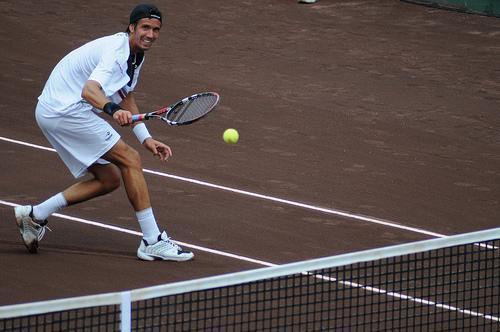How many people?
Give a very brief answer. 1. 